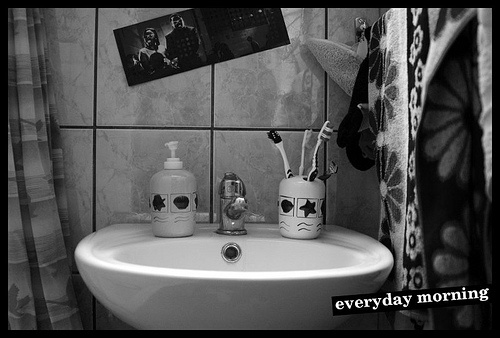Describe the objects in this image and their specific colors. I can see sink in black, gray, darkgray, and lightgray tones, bottle in gray, darkgray, and black tones, people in black and gray tones, people in black and gray tones, and toothbrush in black, gray, darkgray, and lightgray tones in this image. 